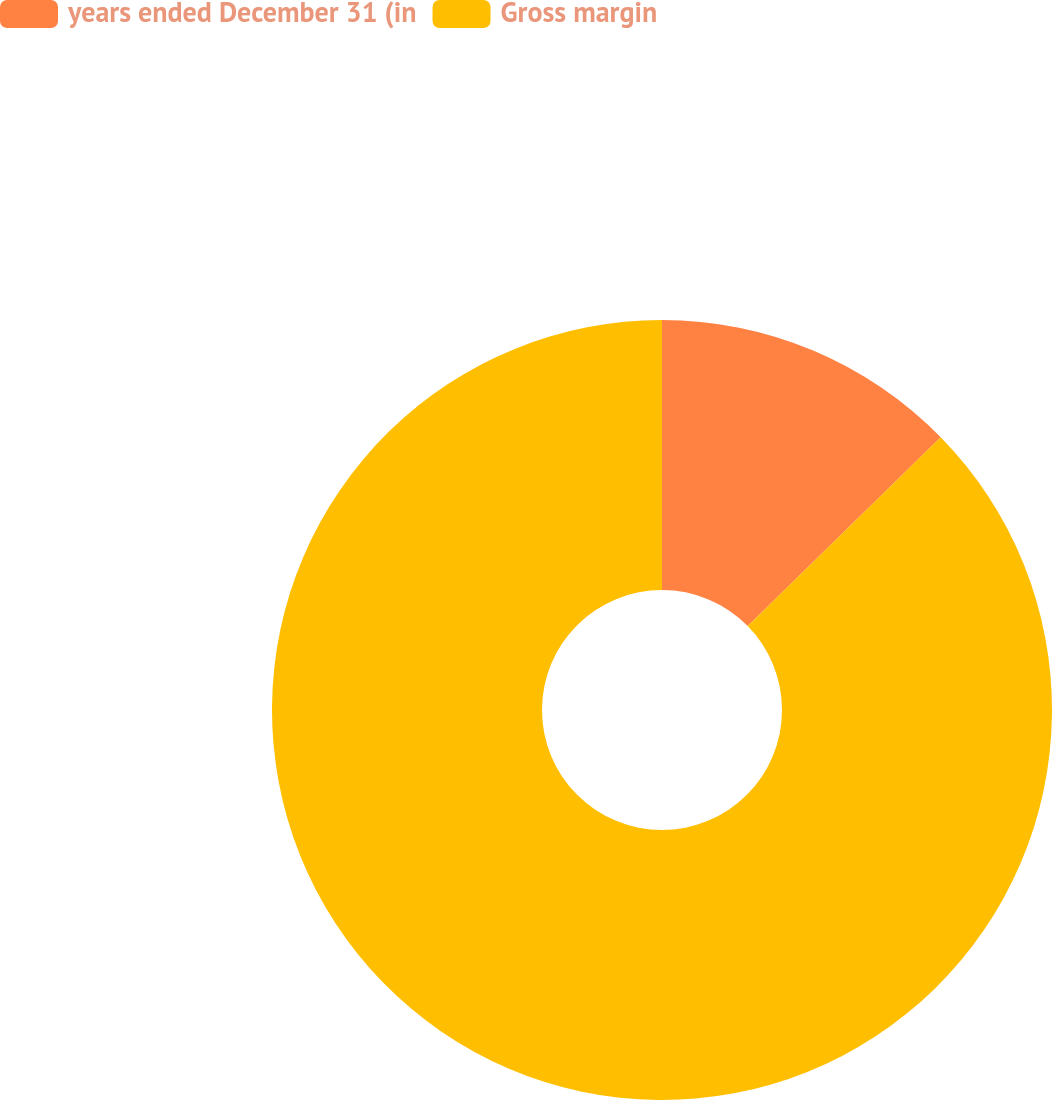Convert chart to OTSL. <chart><loc_0><loc_0><loc_500><loc_500><pie_chart><fcel>years ended December 31 (in<fcel>Gross margin<nl><fcel>12.67%<fcel>87.33%<nl></chart> 